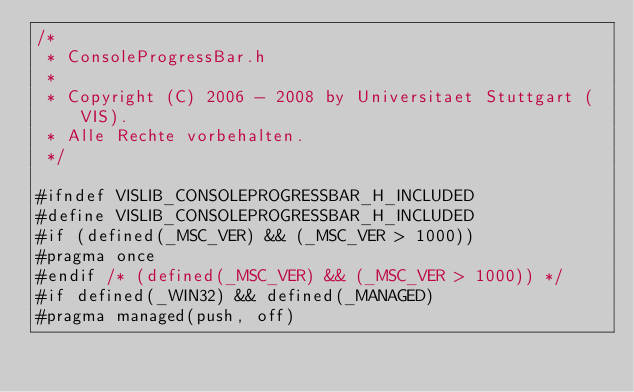<code> <loc_0><loc_0><loc_500><loc_500><_C_>/*
 * ConsoleProgressBar.h
 *
 * Copyright (C) 2006 - 2008 by Universitaet Stuttgart (VIS). 
 * Alle Rechte vorbehalten.
 */

#ifndef VISLIB_CONSOLEPROGRESSBAR_H_INCLUDED
#define VISLIB_CONSOLEPROGRESSBAR_H_INCLUDED
#if (defined(_MSC_VER) && (_MSC_VER > 1000))
#pragma once
#endif /* (defined(_MSC_VER) && (_MSC_VER > 1000)) */
#if defined(_WIN32) && defined(_MANAGED)
#pragma managed(push, off)</code> 